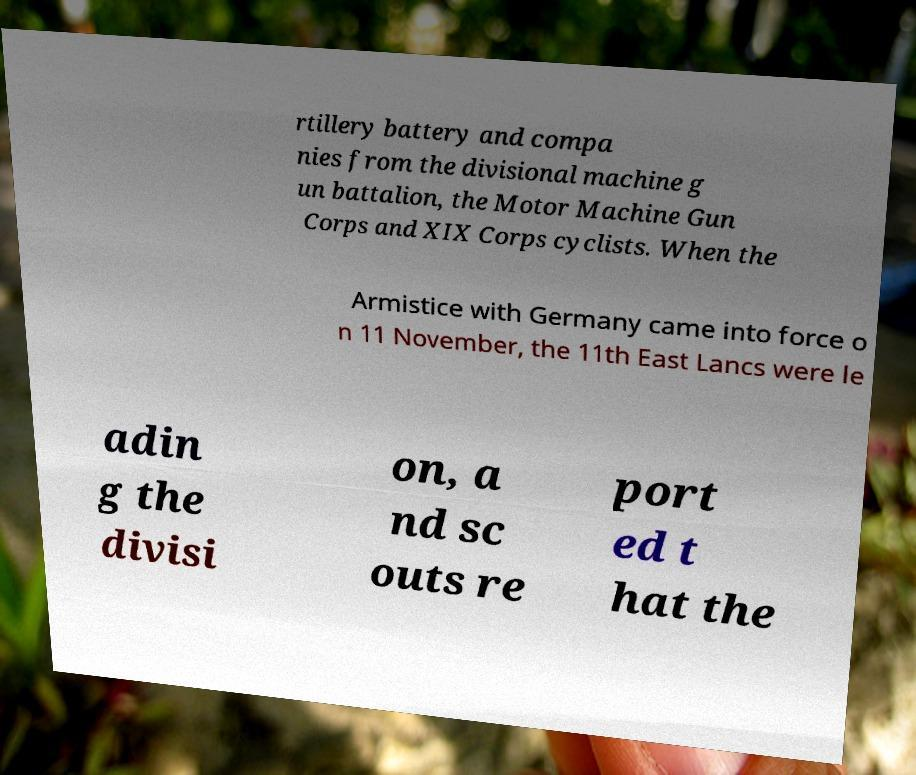There's text embedded in this image that I need extracted. Can you transcribe it verbatim? rtillery battery and compa nies from the divisional machine g un battalion, the Motor Machine Gun Corps and XIX Corps cyclists. When the Armistice with Germany came into force o n 11 November, the 11th East Lancs were le adin g the divisi on, a nd sc outs re port ed t hat the 